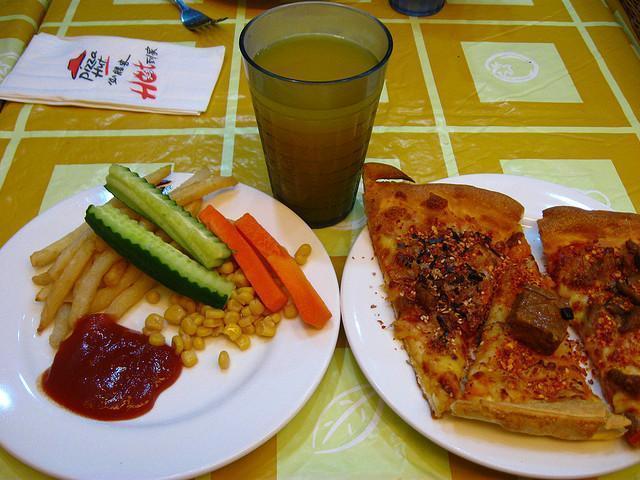How many slices of pizza is there?
Give a very brief answer. 3. How many carrots can you see?
Give a very brief answer. 2. How many pizzas can you see?
Give a very brief answer. 2. How many dining tables can be seen?
Give a very brief answer. 1. 